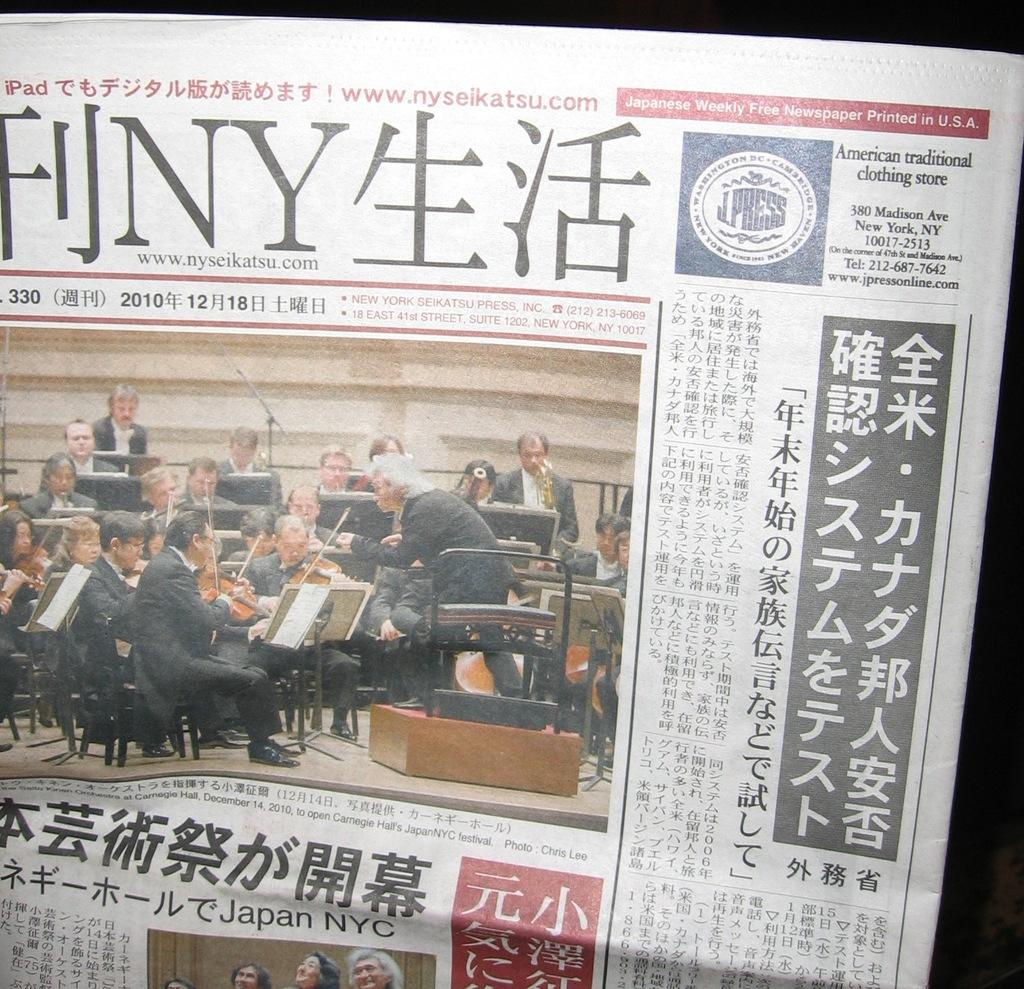<image>
Share a concise interpretation of the image provided. a newspaper that says 'printed in U.S.A.' on the top 